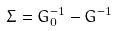Convert formula to latex. <formula><loc_0><loc_0><loc_500><loc_500>\Sigma = G _ { 0 } ^ { - 1 } - G ^ { - 1 }</formula> 